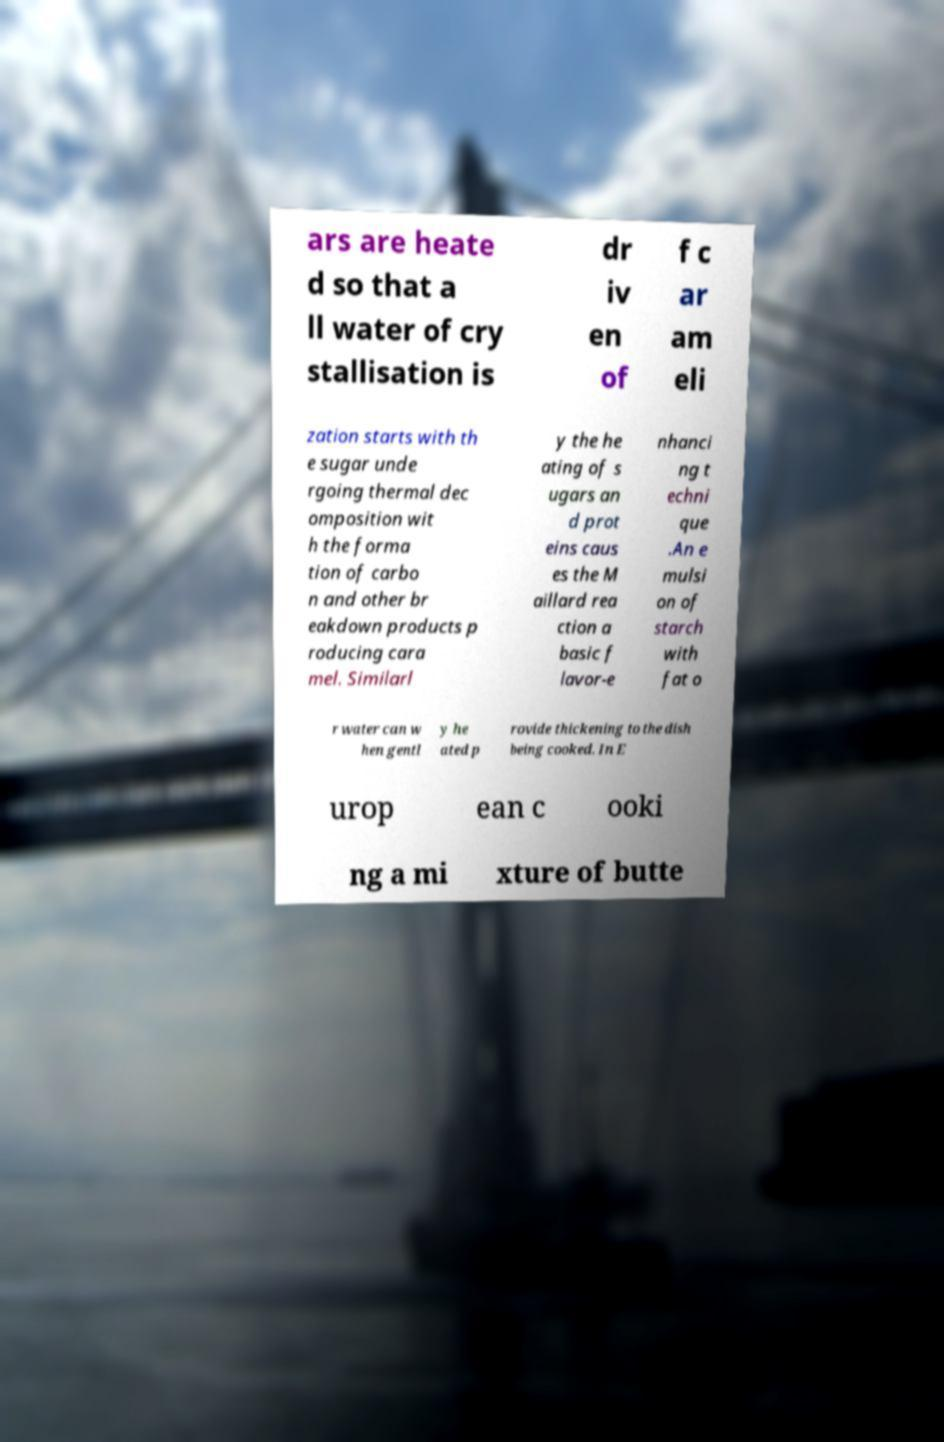Could you extract and type out the text from this image? ars are heate d so that a ll water of cry stallisation is dr iv en of f c ar am eli zation starts with th e sugar unde rgoing thermal dec omposition wit h the forma tion of carbo n and other br eakdown products p roducing cara mel. Similarl y the he ating of s ugars an d prot eins caus es the M aillard rea ction a basic f lavor-e nhanci ng t echni que .An e mulsi on of starch with fat o r water can w hen gentl y he ated p rovide thickening to the dish being cooked. In E urop ean c ooki ng a mi xture of butte 